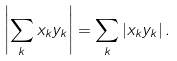Convert formula to latex. <formula><loc_0><loc_0><loc_500><loc_500>\left | \sum _ { k } x _ { k } y _ { k } \right | = \sum _ { k } \left | x _ { k } y _ { k } \right | .</formula> 